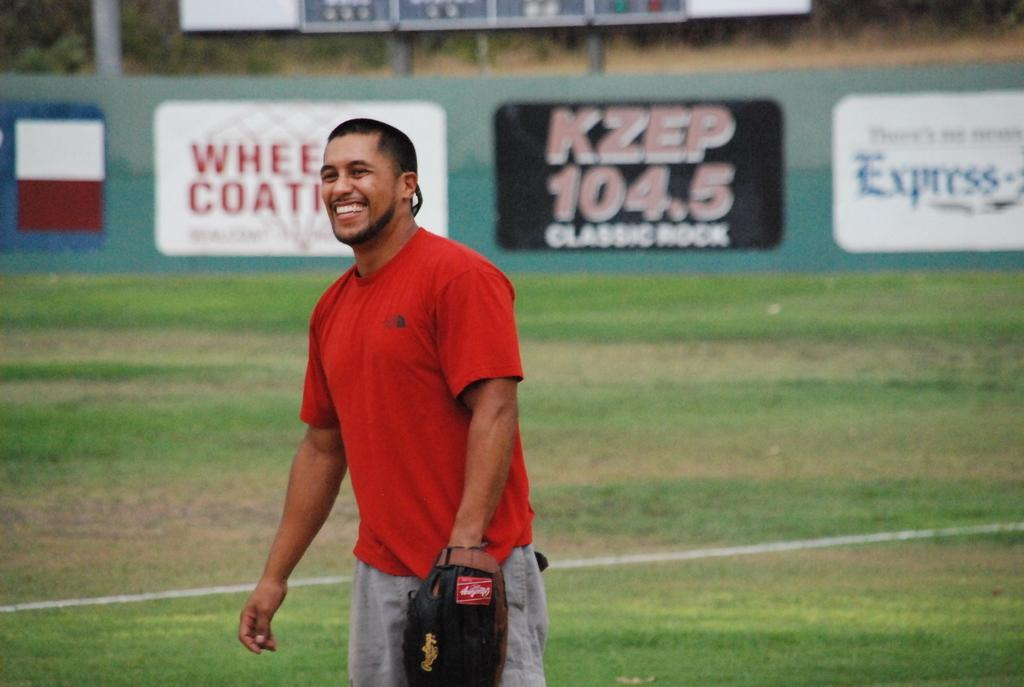Who is present in the image? There is a man in the image. What is the man wearing on his hand? The man is wearing a glove. What is the man's position in the image? The man is standing on the ground. What is the man's facial expression in the image? The man is smiling. What can be seen in the background of the image? There is an advertisement board in the background of the image. What type of notebook is the man using to write his thoughts in the image? There is no notebook present in the image, and the man is not writing anything. 